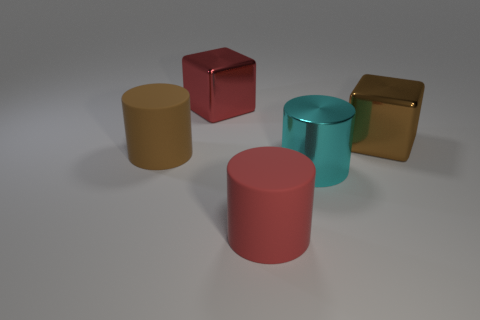Add 1 big red cubes. How many objects exist? 6 Subtract all rubber cylinders. How many cylinders are left? 1 Subtract all cubes. How many objects are left? 3 Add 2 brown matte cylinders. How many brown matte cylinders exist? 3 Subtract all brown blocks. How many blocks are left? 1 Subtract 0 gray balls. How many objects are left? 5 Subtract 1 cubes. How many cubes are left? 1 Subtract all red cylinders. Subtract all purple spheres. How many cylinders are left? 2 Subtract all green blocks. How many brown cylinders are left? 1 Subtract all matte objects. Subtract all purple spheres. How many objects are left? 3 